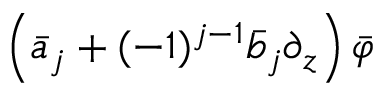<formula> <loc_0><loc_0><loc_500><loc_500>\left ( \bar { a } _ { j } + ( - 1 ) ^ { j - 1 } \bar { b } _ { j } \partial _ { z } \right ) \bar { \varphi }</formula> 